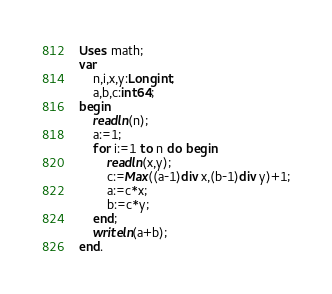<code> <loc_0><loc_0><loc_500><loc_500><_Pascal_>Uses math;
var
	n,i,x,y:Longint;
	a,b,c:int64;
begin
	readln(n);
	a:=1;
	for i:=1 to n do begin
		readln(x,y);
        c:=Max((a-1)div x,(b-1)div y)+1;
		a:=c*x;
		b:=c*y;
	end;
	writeln(a+b);
end.
</code> 